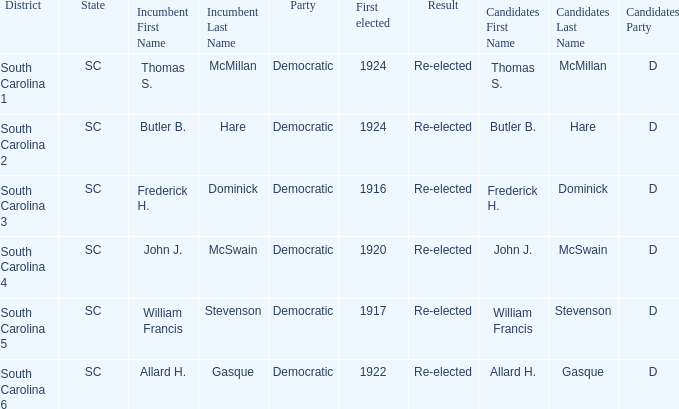Who is the candidate in district south carolina 2? Butler B. Hare (D) Unopposed. 